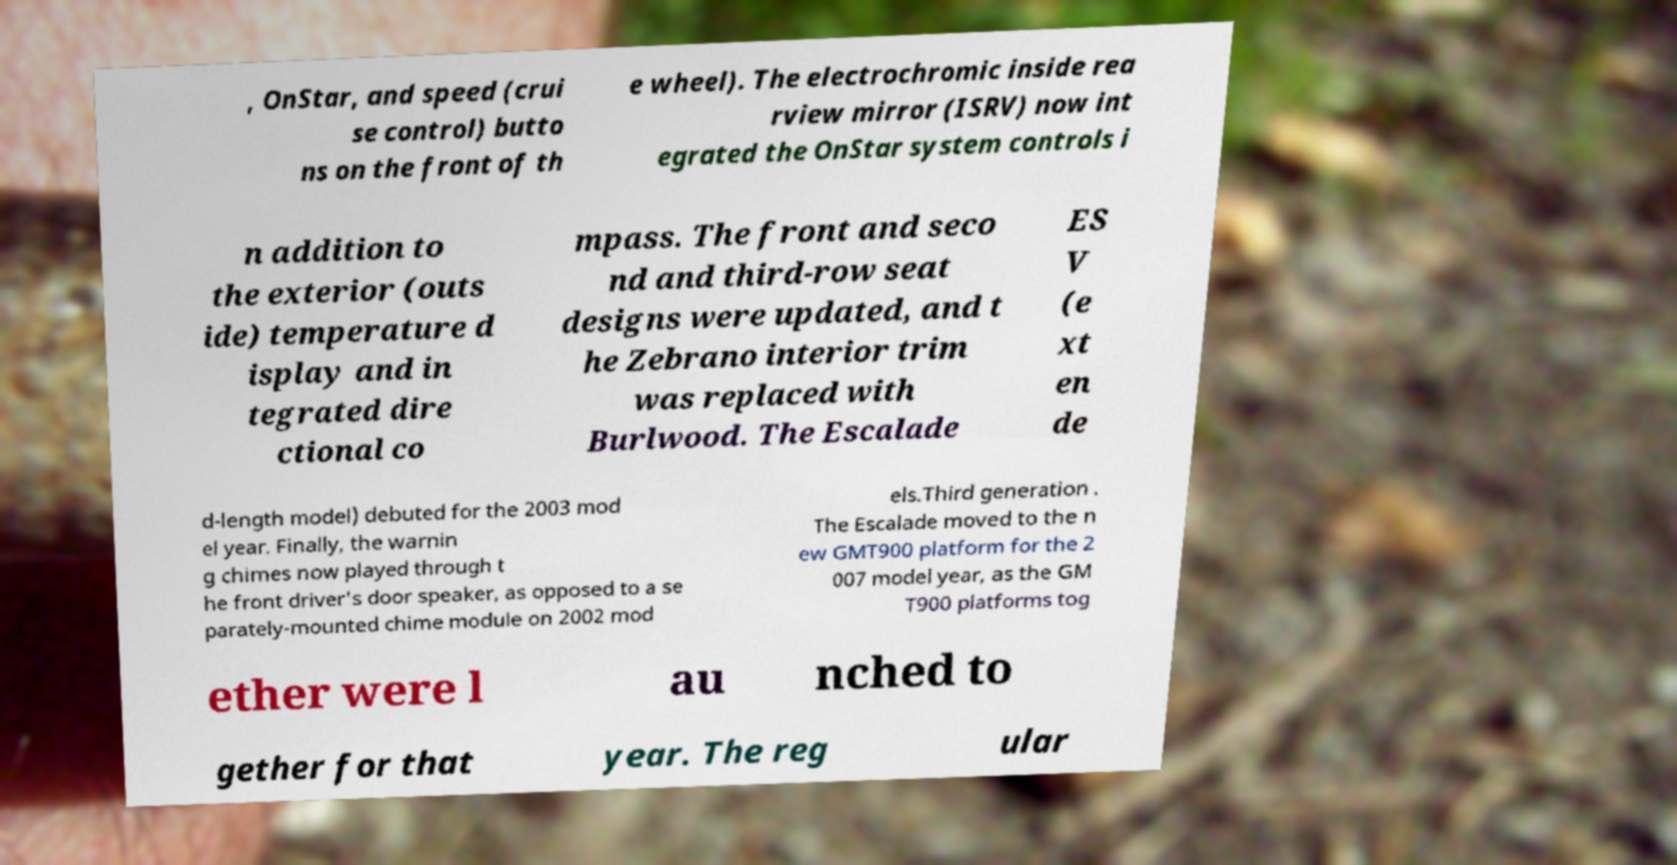Could you extract and type out the text from this image? , OnStar, and speed (crui se control) butto ns on the front of th e wheel). The electrochromic inside rea rview mirror (ISRV) now int egrated the OnStar system controls i n addition to the exterior (outs ide) temperature d isplay and in tegrated dire ctional co mpass. The front and seco nd and third-row seat designs were updated, and t he Zebrano interior trim was replaced with Burlwood. The Escalade ES V (e xt en de d-length model) debuted for the 2003 mod el year. Finally, the warnin g chimes now played through t he front driver's door speaker, as opposed to a se parately-mounted chime module on 2002 mod els.Third generation . The Escalade moved to the n ew GMT900 platform for the 2 007 model year, as the GM T900 platforms tog ether were l au nched to gether for that year. The reg ular 